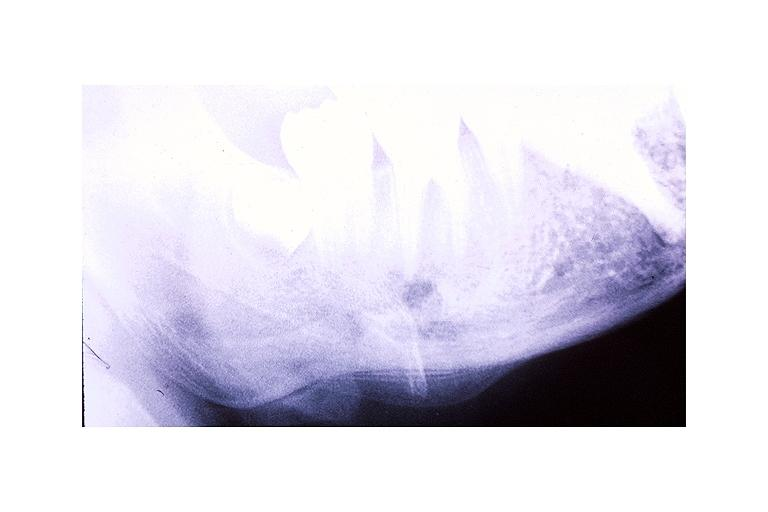what is present?
Answer the question using a single word or phrase. Oral 